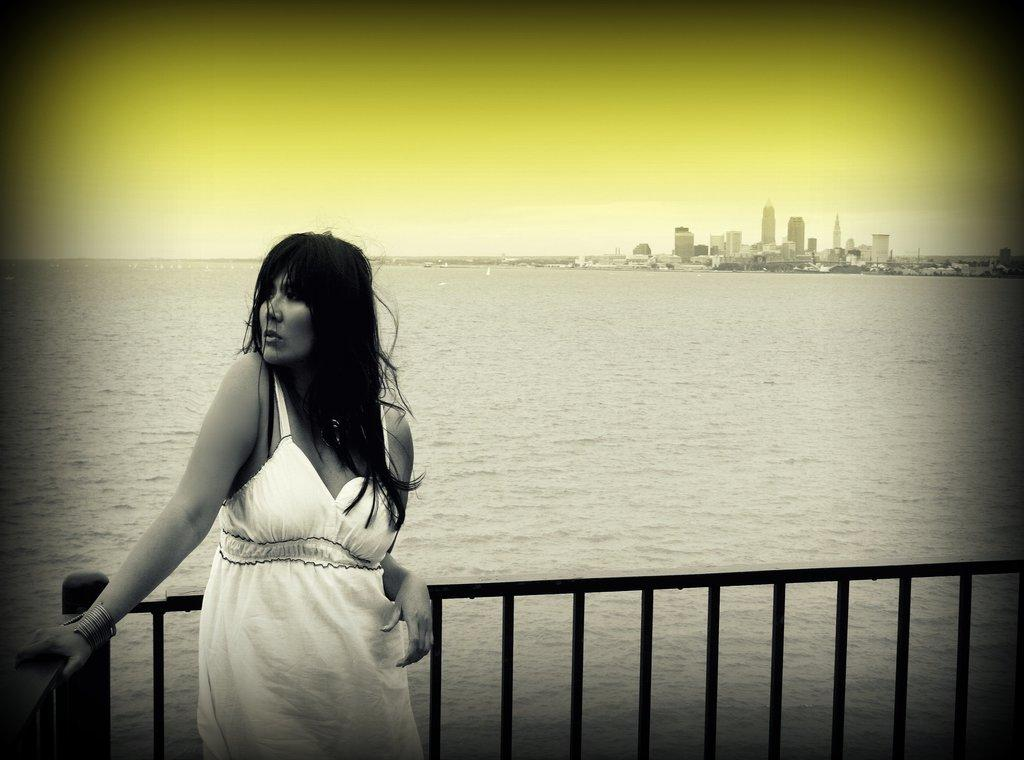What is the woman doing in the image? The woman is standing near the fence in the image. What can be seen in the background of the image? Water, buildings, towers, trees, and the sky are visible in the background of the image. Can you describe the environment in the background? The background features a combination of natural elements, such as water and trees, and man-made structures, including buildings and towers. The sky is also visible. What sound can be heard coming from the woman's leg in the image? There is no sound coming from the woman's leg in the image, and there is no indication of any sound being present. 